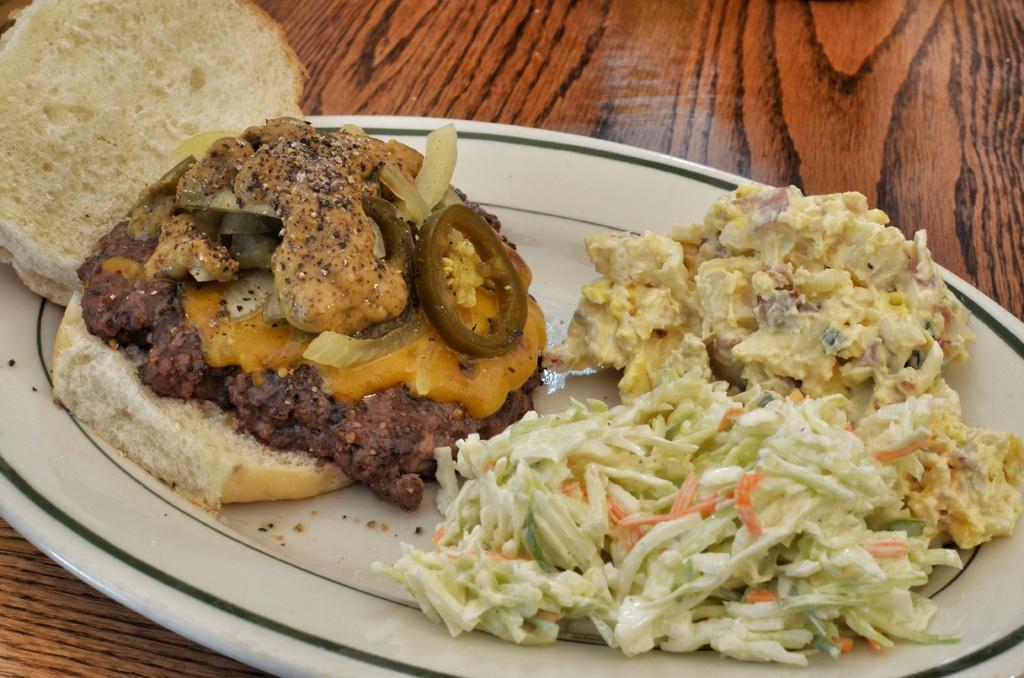Please provide a concise description of this image. On the table there is a white plate. In the plate i can see the meet, cucumber pieces, onion pieces, cabbage and other food items. 